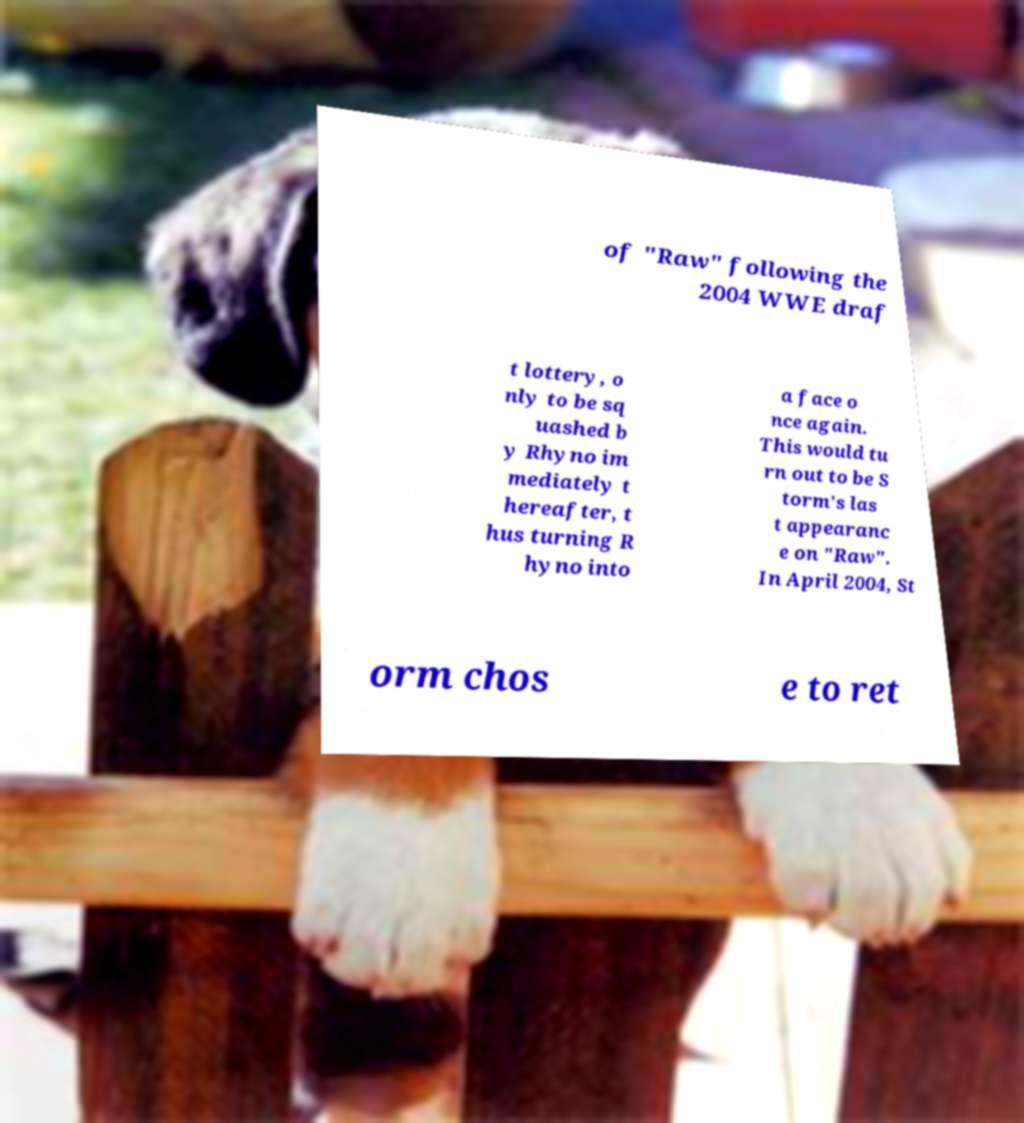I need the written content from this picture converted into text. Can you do that? of "Raw" following the 2004 WWE draf t lottery, o nly to be sq uashed b y Rhyno im mediately t hereafter, t hus turning R hyno into a face o nce again. This would tu rn out to be S torm's las t appearanc e on "Raw". In April 2004, St orm chos e to ret 